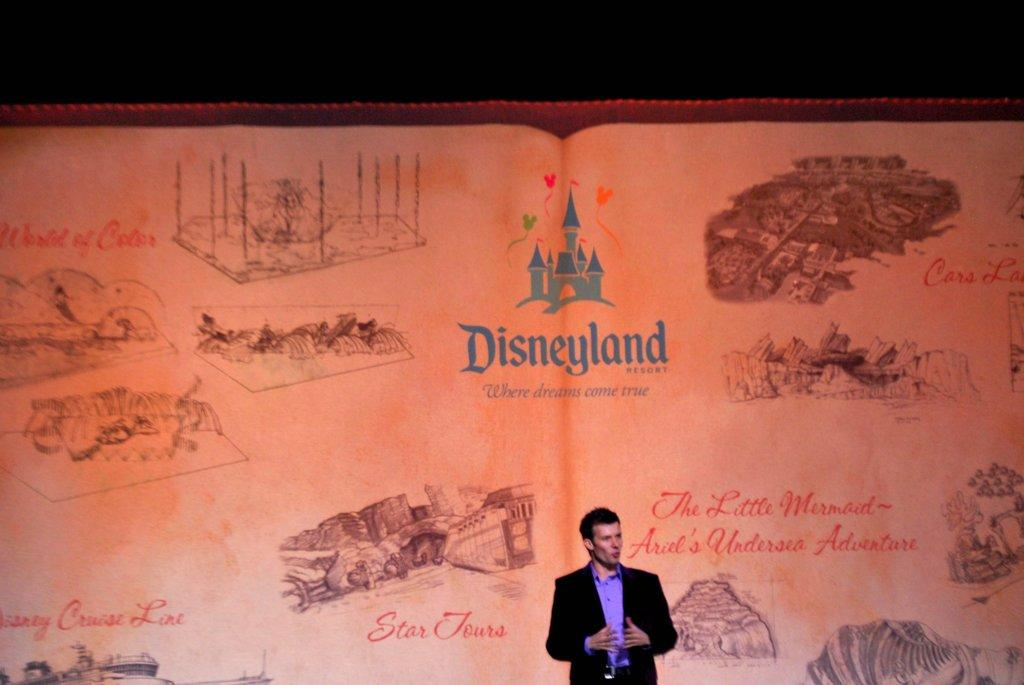What is present in the image? There is a person in the image. What can be observed about the person's attire? The person is wearing clothes. What is the person doing in the image? The person is talking. What can be seen in the background of the image? There is a screen in the background of the image. What is displayed on the screen? The screen has pictures and text printed on it. Can you hear the cow coughing in the image? There is no cow or coughing sound present in the image. 